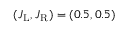<formula> <loc_0><loc_0><loc_500><loc_500>( J _ { L } , J _ { R } ) = ( 0 . 5 , 0 . 5 )</formula> 